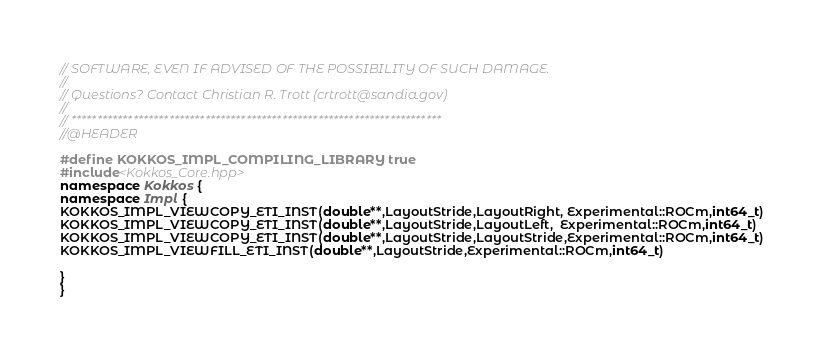<code> <loc_0><loc_0><loc_500><loc_500><_C++_>// SOFTWARE, EVEN IF ADVISED OF THE POSSIBILITY OF SUCH DAMAGE.
//
// Questions? Contact Christian R. Trott (crtrott@sandia.gov)
// 
// ************************************************************************
//@HEADER

#define KOKKOS_IMPL_COMPILING_LIBRARY true
#include<Kokkos_Core.hpp>
namespace Kokkos {
namespace Impl {
KOKKOS_IMPL_VIEWCOPY_ETI_INST(double**,LayoutStride,LayoutRight, Experimental::ROCm,int64_t)
KOKKOS_IMPL_VIEWCOPY_ETI_INST(double**,LayoutStride,LayoutLeft,  Experimental::ROCm,int64_t)
KOKKOS_IMPL_VIEWCOPY_ETI_INST(double**,LayoutStride,LayoutStride,Experimental::ROCm,int64_t)
KOKKOS_IMPL_VIEWFILL_ETI_INST(double**,LayoutStride,Experimental::ROCm,int64_t)

}
}
</code> 